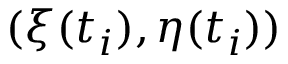<formula> <loc_0><loc_0><loc_500><loc_500>( \xi ( t _ { i } ) , \eta ( t _ { i } ) )</formula> 